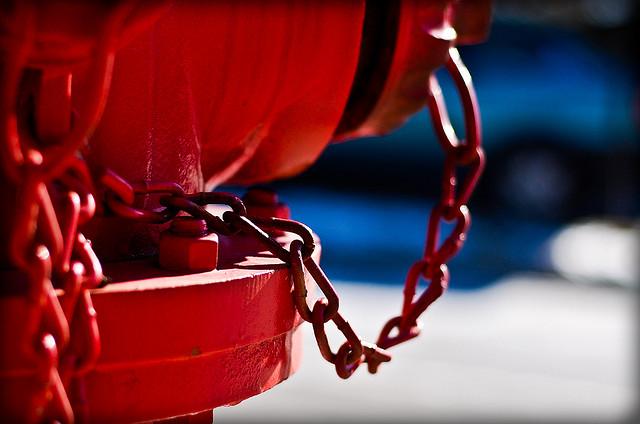What object is this?
Write a very short answer. Fire hydrant. What color is the hydrant?
Write a very short answer. Red. Can a fireman use this object?
Short answer required. Yes. 